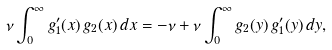<formula> <loc_0><loc_0><loc_500><loc_500>\nu \int _ { 0 } ^ { \infty } g _ { 1 } ^ { \prime } ( x ) \, g _ { 2 } ( x ) \, d x = - \nu + \nu \int _ { 0 } ^ { \infty } g _ { 2 } ( y ) \, g _ { 1 } ^ { \prime } ( y ) \, d y ,</formula> 